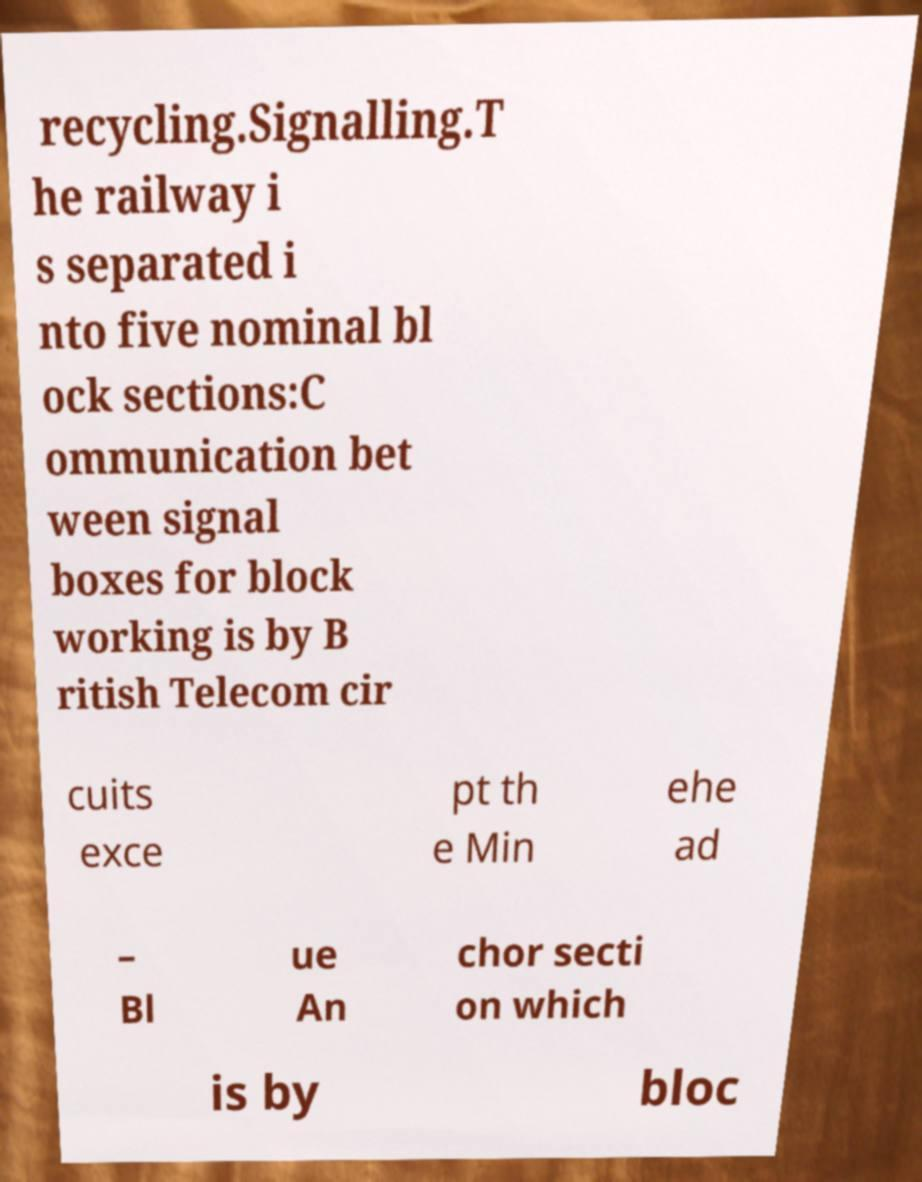I need the written content from this picture converted into text. Can you do that? recycling.Signalling.T he railway i s separated i nto five nominal bl ock sections:C ommunication bet ween signal boxes for block working is by B ritish Telecom cir cuits exce pt th e Min ehe ad – Bl ue An chor secti on which is by bloc 